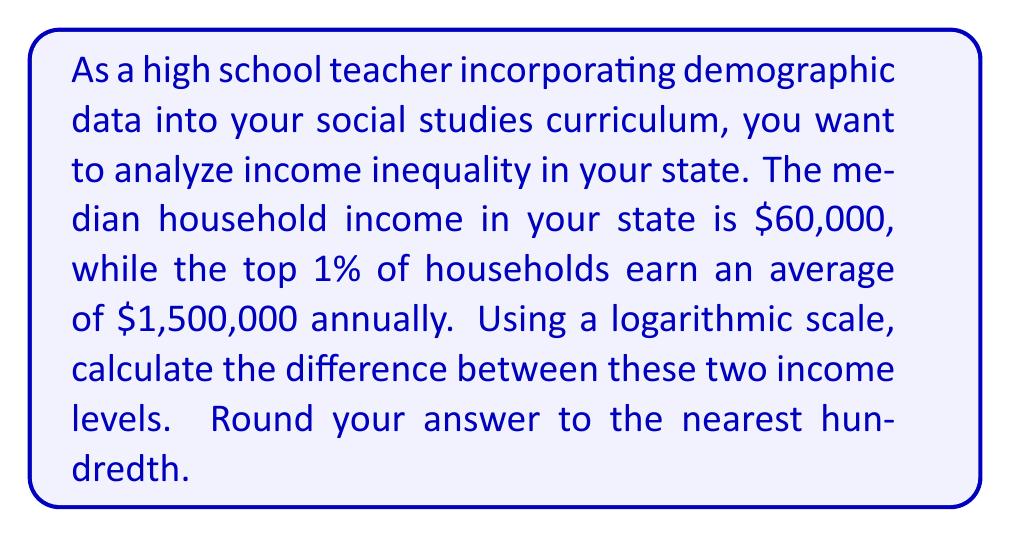Teach me how to tackle this problem. To analyze income inequality using a logarithmic scale, we'll use the logarithm (base 10) of the income values. This allows us to compare values that differ by orders of magnitude more easily.

Step 1: Calculate the logarithm of the median household income.
$$\log_{10}(60,000) = 4.7781$$

Step 2: Calculate the logarithm of the top 1% average income.
$$\log_{10}(1,500,000) = 6.1761$$

Step 3: Calculate the difference between these two logarithmic values.
$$6.1761 - 4.7781 = 1.3980$$

Step 4: Round the result to the nearest hundredth.
$$1.3980 \approx 1.40$$

This logarithmic difference represents the scale of income inequality. Each whole number in this scale represents a factor of 10 in actual income. So, a difference of 1.40 indicates that the top 1% earn about $10^{1.40} \approx 25.12$ times more than the median household.
Answer: The difference between the two income levels on a logarithmic scale is 1.40. 